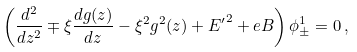<formula> <loc_0><loc_0><loc_500><loc_500>\left ( \frac { d ^ { 2 } } { d z ^ { 2 } } \mp \xi \frac { d g ( z ) } { d z } - \xi ^ { 2 } g ^ { 2 } ( z ) + { E ^ { \prime } } ^ { 2 } + e B \right ) \phi _ { \pm } ^ { 1 } = 0 \, ,</formula> 